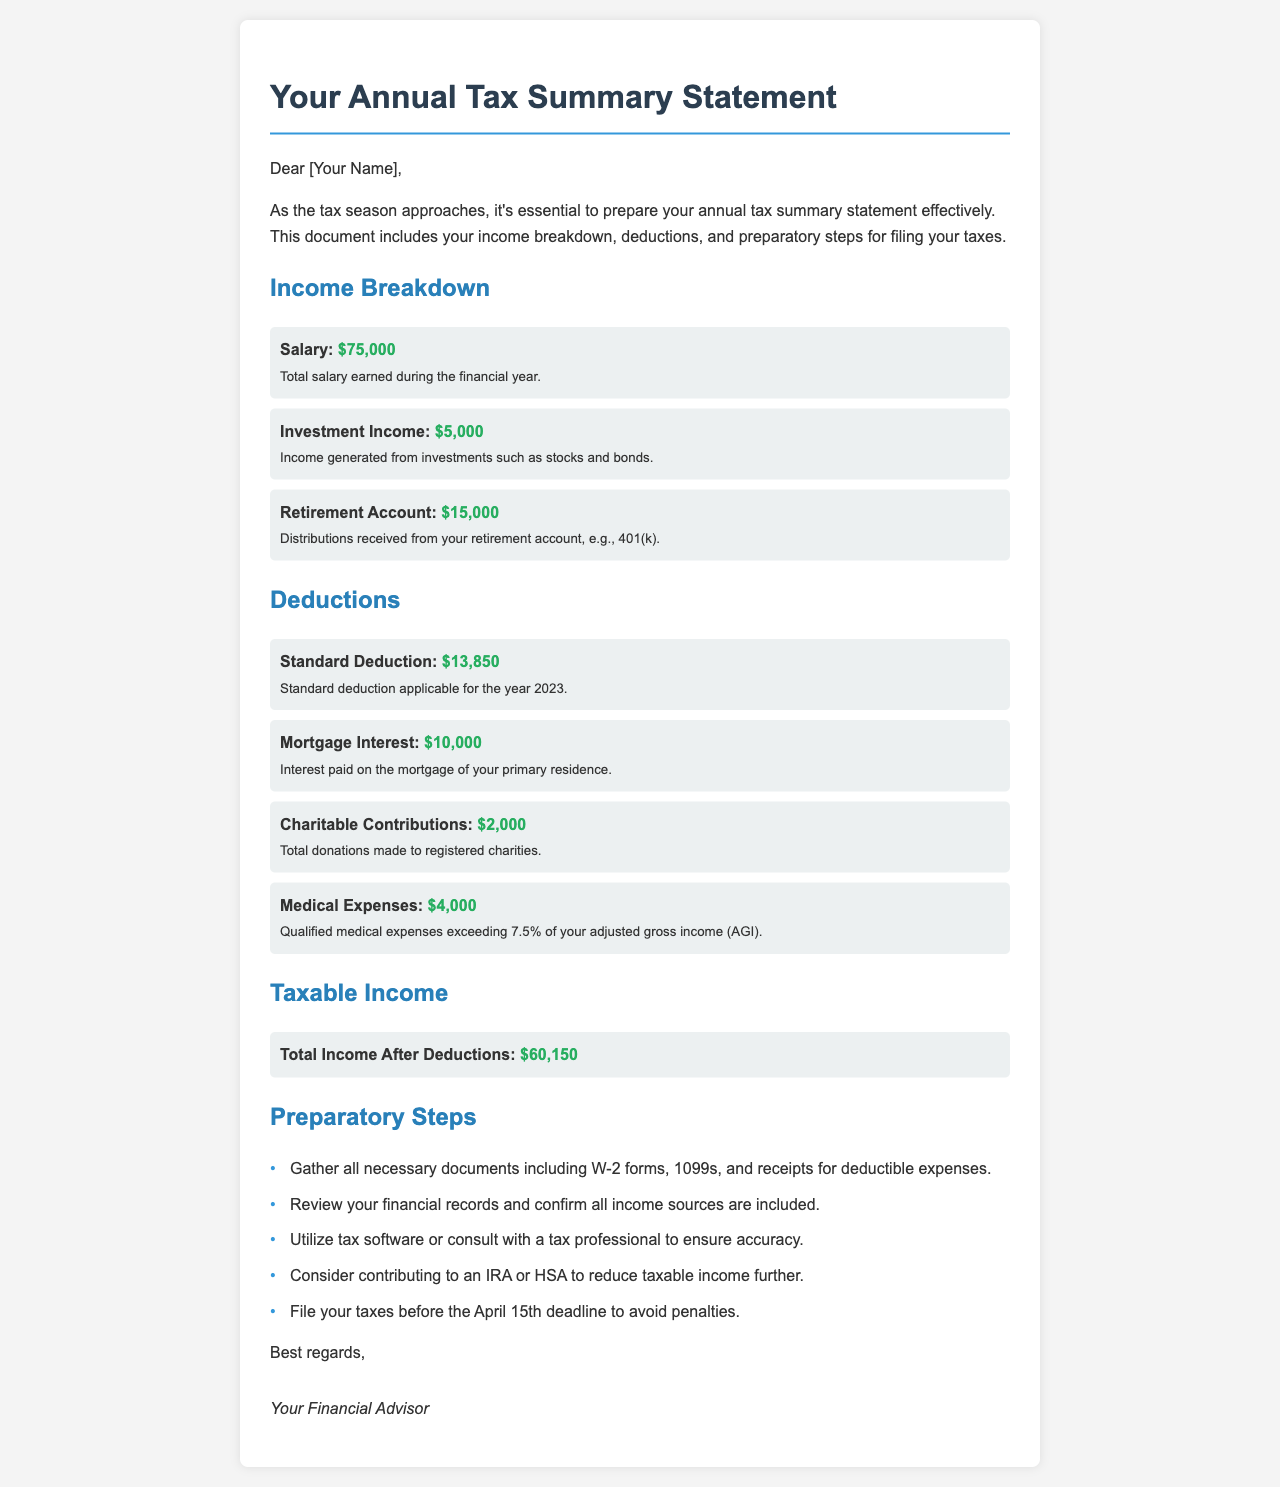What is the total salary earned? The total salary earned is mentioned in the income breakdown section of the document, which is $75,000.
Answer: $75,000 How much was earned from investments? The income generated from investments, as stated in the document, is $5,000.
Answer: $5,000 What is the standard deduction for 2023? The standard deduction applicable for the year 2023 is specified as $13,850.
Answer: $13,850 What is the total medical expenses deduction? The qualified medical expenses deduction is $4,000, as detailed in the deductions section.
Answer: $4,000 What is the total income after deductions? The total income after accounting for deductions is highlighted in the document as $60,150.
Answer: $60,150 How many steps are listed in preparatory steps? There are five preparatory steps outlined in the document for filing taxes.
Answer: 5 What is the deadline to file taxes? The document specifies that the deadline to file taxes is April 15th.
Answer: April 15th What is the amount received from retirement account distributions? The amount received from retirement account distributions is listed as $15,000.
Answer: $15,000 What type of document is this? The document is an Annual Tax Summary Statement as indicated in the title.
Answer: Annual Tax Summary Statement 